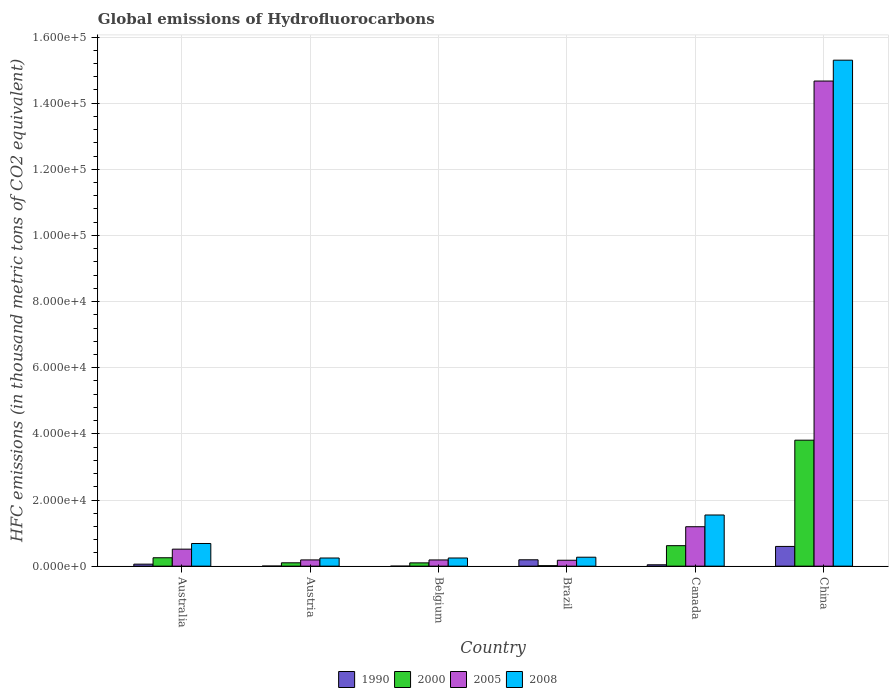What is the label of the 4th group of bars from the left?
Your response must be concise. Brazil. In how many cases, is the number of bars for a given country not equal to the number of legend labels?
Your response must be concise. 0. What is the global emissions of Hydrofluorocarbons in 1990 in Canada?
Your answer should be compact. 418.5. Across all countries, what is the maximum global emissions of Hydrofluorocarbons in 1990?
Give a very brief answer. 5970.1. Across all countries, what is the minimum global emissions of Hydrofluorocarbons in 2005?
Make the answer very short. 1793.4. In which country was the global emissions of Hydrofluorocarbons in 1990 maximum?
Your answer should be very brief. China. In which country was the global emissions of Hydrofluorocarbons in 2000 minimum?
Ensure brevity in your answer.  Brazil. What is the total global emissions of Hydrofluorocarbons in 2000 in the graph?
Offer a terse response. 4.90e+04. What is the difference between the global emissions of Hydrofluorocarbons in 2005 in Australia and that in China?
Your response must be concise. -1.42e+05. What is the difference between the global emissions of Hydrofluorocarbons in 2000 in Belgium and the global emissions of Hydrofluorocarbons in 2008 in Austria?
Make the answer very short. -1471.2. What is the average global emissions of Hydrofluorocarbons in 2000 per country?
Offer a very short reply. 8167.67. What is the difference between the global emissions of Hydrofluorocarbons of/in 2005 and global emissions of Hydrofluorocarbons of/in 2000 in Brazil?
Provide a short and direct response. 1646. In how many countries, is the global emissions of Hydrofluorocarbons in 1990 greater than 112000 thousand metric tons?
Your response must be concise. 0. What is the ratio of the global emissions of Hydrofluorocarbons in 2000 in Austria to that in Brazil?
Offer a very short reply. 6.91. What is the difference between the highest and the second highest global emissions of Hydrofluorocarbons in 1990?
Offer a very short reply. 5357.6. What is the difference between the highest and the lowest global emissions of Hydrofluorocarbons in 2000?
Your answer should be very brief. 3.79e+04. In how many countries, is the global emissions of Hydrofluorocarbons in 2000 greater than the average global emissions of Hydrofluorocarbons in 2000 taken over all countries?
Provide a succinct answer. 1. Is the sum of the global emissions of Hydrofluorocarbons in 2000 in Australia and Belgium greater than the maximum global emissions of Hydrofluorocarbons in 1990 across all countries?
Your response must be concise. No. Are all the bars in the graph horizontal?
Ensure brevity in your answer.  No. How many countries are there in the graph?
Keep it short and to the point. 6. What is the difference between two consecutive major ticks on the Y-axis?
Keep it short and to the point. 2.00e+04. Does the graph contain grids?
Provide a succinct answer. Yes. How many legend labels are there?
Give a very brief answer. 4. What is the title of the graph?
Make the answer very short. Global emissions of Hydrofluorocarbons. Does "1995" appear as one of the legend labels in the graph?
Your answer should be very brief. No. What is the label or title of the Y-axis?
Provide a short and direct response. HFC emissions (in thousand metric tons of CO2 equivalent). What is the HFC emissions (in thousand metric tons of CO2 equivalent) in 1990 in Australia?
Provide a succinct answer. 612.5. What is the HFC emissions (in thousand metric tons of CO2 equivalent) in 2000 in Australia?
Your answer should be compact. 2545.7. What is the HFC emissions (in thousand metric tons of CO2 equivalent) of 2005 in Australia?
Provide a short and direct response. 5145.6. What is the HFC emissions (in thousand metric tons of CO2 equivalent) in 2008 in Australia?
Provide a succinct answer. 6857.4. What is the HFC emissions (in thousand metric tons of CO2 equivalent) in 1990 in Austria?
Keep it short and to the point. 30.9. What is the HFC emissions (in thousand metric tons of CO2 equivalent) of 2000 in Austria?
Provide a short and direct response. 1018.4. What is the HFC emissions (in thousand metric tons of CO2 equivalent) of 2005 in Austria?
Your answer should be compact. 1891.2. What is the HFC emissions (in thousand metric tons of CO2 equivalent) of 2008 in Austria?
Offer a terse response. 2468.9. What is the HFC emissions (in thousand metric tons of CO2 equivalent) of 2000 in Belgium?
Provide a short and direct response. 997.7. What is the HFC emissions (in thousand metric tons of CO2 equivalent) of 2005 in Belgium?
Make the answer very short. 1882.6. What is the HFC emissions (in thousand metric tons of CO2 equivalent) of 2008 in Belgium?
Provide a short and direct response. 2471.1. What is the HFC emissions (in thousand metric tons of CO2 equivalent) of 1990 in Brazil?
Provide a short and direct response. 1930.7. What is the HFC emissions (in thousand metric tons of CO2 equivalent) of 2000 in Brazil?
Provide a succinct answer. 147.4. What is the HFC emissions (in thousand metric tons of CO2 equivalent) in 2005 in Brazil?
Your answer should be very brief. 1793.4. What is the HFC emissions (in thousand metric tons of CO2 equivalent) in 2008 in Brazil?
Make the answer very short. 2707.5. What is the HFC emissions (in thousand metric tons of CO2 equivalent) of 1990 in Canada?
Your response must be concise. 418.5. What is the HFC emissions (in thousand metric tons of CO2 equivalent) of 2000 in Canada?
Your answer should be compact. 6202.8. What is the HFC emissions (in thousand metric tons of CO2 equivalent) of 2005 in Canada?
Offer a terse response. 1.19e+04. What is the HFC emissions (in thousand metric tons of CO2 equivalent) of 2008 in Canada?
Your answer should be compact. 1.55e+04. What is the HFC emissions (in thousand metric tons of CO2 equivalent) in 1990 in China?
Provide a succinct answer. 5970.1. What is the HFC emissions (in thousand metric tons of CO2 equivalent) in 2000 in China?
Offer a terse response. 3.81e+04. What is the HFC emissions (in thousand metric tons of CO2 equivalent) in 2005 in China?
Provide a succinct answer. 1.47e+05. What is the HFC emissions (in thousand metric tons of CO2 equivalent) of 2008 in China?
Make the answer very short. 1.53e+05. Across all countries, what is the maximum HFC emissions (in thousand metric tons of CO2 equivalent) in 1990?
Offer a very short reply. 5970.1. Across all countries, what is the maximum HFC emissions (in thousand metric tons of CO2 equivalent) in 2000?
Make the answer very short. 3.81e+04. Across all countries, what is the maximum HFC emissions (in thousand metric tons of CO2 equivalent) in 2005?
Your answer should be compact. 1.47e+05. Across all countries, what is the maximum HFC emissions (in thousand metric tons of CO2 equivalent) in 2008?
Make the answer very short. 1.53e+05. Across all countries, what is the minimum HFC emissions (in thousand metric tons of CO2 equivalent) of 2000?
Offer a very short reply. 147.4. Across all countries, what is the minimum HFC emissions (in thousand metric tons of CO2 equivalent) of 2005?
Give a very brief answer. 1793.4. Across all countries, what is the minimum HFC emissions (in thousand metric tons of CO2 equivalent) in 2008?
Provide a short and direct response. 2468.9. What is the total HFC emissions (in thousand metric tons of CO2 equivalent) in 1990 in the graph?
Make the answer very short. 8963.2. What is the total HFC emissions (in thousand metric tons of CO2 equivalent) of 2000 in the graph?
Offer a very short reply. 4.90e+04. What is the total HFC emissions (in thousand metric tons of CO2 equivalent) of 2005 in the graph?
Your response must be concise. 1.69e+05. What is the total HFC emissions (in thousand metric tons of CO2 equivalent) in 2008 in the graph?
Provide a succinct answer. 1.83e+05. What is the difference between the HFC emissions (in thousand metric tons of CO2 equivalent) of 1990 in Australia and that in Austria?
Ensure brevity in your answer.  581.6. What is the difference between the HFC emissions (in thousand metric tons of CO2 equivalent) of 2000 in Australia and that in Austria?
Your response must be concise. 1527.3. What is the difference between the HFC emissions (in thousand metric tons of CO2 equivalent) of 2005 in Australia and that in Austria?
Keep it short and to the point. 3254.4. What is the difference between the HFC emissions (in thousand metric tons of CO2 equivalent) of 2008 in Australia and that in Austria?
Make the answer very short. 4388.5. What is the difference between the HFC emissions (in thousand metric tons of CO2 equivalent) in 1990 in Australia and that in Belgium?
Provide a short and direct response. 612. What is the difference between the HFC emissions (in thousand metric tons of CO2 equivalent) in 2000 in Australia and that in Belgium?
Keep it short and to the point. 1548. What is the difference between the HFC emissions (in thousand metric tons of CO2 equivalent) in 2005 in Australia and that in Belgium?
Offer a very short reply. 3263. What is the difference between the HFC emissions (in thousand metric tons of CO2 equivalent) of 2008 in Australia and that in Belgium?
Offer a very short reply. 4386.3. What is the difference between the HFC emissions (in thousand metric tons of CO2 equivalent) in 1990 in Australia and that in Brazil?
Your response must be concise. -1318.2. What is the difference between the HFC emissions (in thousand metric tons of CO2 equivalent) in 2000 in Australia and that in Brazil?
Offer a terse response. 2398.3. What is the difference between the HFC emissions (in thousand metric tons of CO2 equivalent) of 2005 in Australia and that in Brazil?
Make the answer very short. 3352.2. What is the difference between the HFC emissions (in thousand metric tons of CO2 equivalent) of 2008 in Australia and that in Brazil?
Provide a short and direct response. 4149.9. What is the difference between the HFC emissions (in thousand metric tons of CO2 equivalent) of 1990 in Australia and that in Canada?
Your response must be concise. 194. What is the difference between the HFC emissions (in thousand metric tons of CO2 equivalent) of 2000 in Australia and that in Canada?
Your response must be concise. -3657.1. What is the difference between the HFC emissions (in thousand metric tons of CO2 equivalent) of 2005 in Australia and that in Canada?
Provide a succinct answer. -6782.8. What is the difference between the HFC emissions (in thousand metric tons of CO2 equivalent) of 2008 in Australia and that in Canada?
Make the answer very short. -8617.4. What is the difference between the HFC emissions (in thousand metric tons of CO2 equivalent) in 1990 in Australia and that in China?
Your response must be concise. -5357.6. What is the difference between the HFC emissions (in thousand metric tons of CO2 equivalent) in 2000 in Australia and that in China?
Your response must be concise. -3.55e+04. What is the difference between the HFC emissions (in thousand metric tons of CO2 equivalent) in 2005 in Australia and that in China?
Make the answer very short. -1.42e+05. What is the difference between the HFC emissions (in thousand metric tons of CO2 equivalent) of 2008 in Australia and that in China?
Offer a very short reply. -1.46e+05. What is the difference between the HFC emissions (in thousand metric tons of CO2 equivalent) in 1990 in Austria and that in Belgium?
Provide a short and direct response. 30.4. What is the difference between the HFC emissions (in thousand metric tons of CO2 equivalent) of 2000 in Austria and that in Belgium?
Keep it short and to the point. 20.7. What is the difference between the HFC emissions (in thousand metric tons of CO2 equivalent) in 2008 in Austria and that in Belgium?
Keep it short and to the point. -2.2. What is the difference between the HFC emissions (in thousand metric tons of CO2 equivalent) in 1990 in Austria and that in Brazil?
Keep it short and to the point. -1899.8. What is the difference between the HFC emissions (in thousand metric tons of CO2 equivalent) of 2000 in Austria and that in Brazil?
Your response must be concise. 871. What is the difference between the HFC emissions (in thousand metric tons of CO2 equivalent) in 2005 in Austria and that in Brazil?
Give a very brief answer. 97.8. What is the difference between the HFC emissions (in thousand metric tons of CO2 equivalent) of 2008 in Austria and that in Brazil?
Provide a succinct answer. -238.6. What is the difference between the HFC emissions (in thousand metric tons of CO2 equivalent) of 1990 in Austria and that in Canada?
Give a very brief answer. -387.6. What is the difference between the HFC emissions (in thousand metric tons of CO2 equivalent) of 2000 in Austria and that in Canada?
Give a very brief answer. -5184.4. What is the difference between the HFC emissions (in thousand metric tons of CO2 equivalent) of 2005 in Austria and that in Canada?
Keep it short and to the point. -1.00e+04. What is the difference between the HFC emissions (in thousand metric tons of CO2 equivalent) of 2008 in Austria and that in Canada?
Ensure brevity in your answer.  -1.30e+04. What is the difference between the HFC emissions (in thousand metric tons of CO2 equivalent) in 1990 in Austria and that in China?
Give a very brief answer. -5939.2. What is the difference between the HFC emissions (in thousand metric tons of CO2 equivalent) in 2000 in Austria and that in China?
Provide a succinct answer. -3.71e+04. What is the difference between the HFC emissions (in thousand metric tons of CO2 equivalent) in 2005 in Austria and that in China?
Your answer should be compact. -1.45e+05. What is the difference between the HFC emissions (in thousand metric tons of CO2 equivalent) in 2008 in Austria and that in China?
Keep it short and to the point. -1.51e+05. What is the difference between the HFC emissions (in thousand metric tons of CO2 equivalent) in 1990 in Belgium and that in Brazil?
Keep it short and to the point. -1930.2. What is the difference between the HFC emissions (in thousand metric tons of CO2 equivalent) in 2000 in Belgium and that in Brazil?
Provide a short and direct response. 850.3. What is the difference between the HFC emissions (in thousand metric tons of CO2 equivalent) of 2005 in Belgium and that in Brazil?
Give a very brief answer. 89.2. What is the difference between the HFC emissions (in thousand metric tons of CO2 equivalent) in 2008 in Belgium and that in Brazil?
Your response must be concise. -236.4. What is the difference between the HFC emissions (in thousand metric tons of CO2 equivalent) in 1990 in Belgium and that in Canada?
Keep it short and to the point. -418. What is the difference between the HFC emissions (in thousand metric tons of CO2 equivalent) in 2000 in Belgium and that in Canada?
Offer a very short reply. -5205.1. What is the difference between the HFC emissions (in thousand metric tons of CO2 equivalent) in 2005 in Belgium and that in Canada?
Provide a succinct answer. -1.00e+04. What is the difference between the HFC emissions (in thousand metric tons of CO2 equivalent) in 2008 in Belgium and that in Canada?
Provide a succinct answer. -1.30e+04. What is the difference between the HFC emissions (in thousand metric tons of CO2 equivalent) of 1990 in Belgium and that in China?
Ensure brevity in your answer.  -5969.6. What is the difference between the HFC emissions (in thousand metric tons of CO2 equivalent) in 2000 in Belgium and that in China?
Ensure brevity in your answer.  -3.71e+04. What is the difference between the HFC emissions (in thousand metric tons of CO2 equivalent) of 2005 in Belgium and that in China?
Your answer should be very brief. -1.45e+05. What is the difference between the HFC emissions (in thousand metric tons of CO2 equivalent) of 2008 in Belgium and that in China?
Offer a terse response. -1.51e+05. What is the difference between the HFC emissions (in thousand metric tons of CO2 equivalent) in 1990 in Brazil and that in Canada?
Make the answer very short. 1512.2. What is the difference between the HFC emissions (in thousand metric tons of CO2 equivalent) in 2000 in Brazil and that in Canada?
Offer a very short reply. -6055.4. What is the difference between the HFC emissions (in thousand metric tons of CO2 equivalent) in 2005 in Brazil and that in Canada?
Your answer should be compact. -1.01e+04. What is the difference between the HFC emissions (in thousand metric tons of CO2 equivalent) of 2008 in Brazil and that in Canada?
Keep it short and to the point. -1.28e+04. What is the difference between the HFC emissions (in thousand metric tons of CO2 equivalent) in 1990 in Brazil and that in China?
Offer a very short reply. -4039.4. What is the difference between the HFC emissions (in thousand metric tons of CO2 equivalent) of 2000 in Brazil and that in China?
Provide a short and direct response. -3.79e+04. What is the difference between the HFC emissions (in thousand metric tons of CO2 equivalent) of 2005 in Brazil and that in China?
Provide a succinct answer. -1.45e+05. What is the difference between the HFC emissions (in thousand metric tons of CO2 equivalent) in 2008 in Brazil and that in China?
Offer a very short reply. -1.50e+05. What is the difference between the HFC emissions (in thousand metric tons of CO2 equivalent) of 1990 in Canada and that in China?
Provide a short and direct response. -5551.6. What is the difference between the HFC emissions (in thousand metric tons of CO2 equivalent) in 2000 in Canada and that in China?
Make the answer very short. -3.19e+04. What is the difference between the HFC emissions (in thousand metric tons of CO2 equivalent) in 2005 in Canada and that in China?
Offer a very short reply. -1.35e+05. What is the difference between the HFC emissions (in thousand metric tons of CO2 equivalent) of 2008 in Canada and that in China?
Your answer should be very brief. -1.38e+05. What is the difference between the HFC emissions (in thousand metric tons of CO2 equivalent) of 1990 in Australia and the HFC emissions (in thousand metric tons of CO2 equivalent) of 2000 in Austria?
Make the answer very short. -405.9. What is the difference between the HFC emissions (in thousand metric tons of CO2 equivalent) of 1990 in Australia and the HFC emissions (in thousand metric tons of CO2 equivalent) of 2005 in Austria?
Give a very brief answer. -1278.7. What is the difference between the HFC emissions (in thousand metric tons of CO2 equivalent) in 1990 in Australia and the HFC emissions (in thousand metric tons of CO2 equivalent) in 2008 in Austria?
Offer a terse response. -1856.4. What is the difference between the HFC emissions (in thousand metric tons of CO2 equivalent) in 2000 in Australia and the HFC emissions (in thousand metric tons of CO2 equivalent) in 2005 in Austria?
Offer a terse response. 654.5. What is the difference between the HFC emissions (in thousand metric tons of CO2 equivalent) of 2000 in Australia and the HFC emissions (in thousand metric tons of CO2 equivalent) of 2008 in Austria?
Ensure brevity in your answer.  76.8. What is the difference between the HFC emissions (in thousand metric tons of CO2 equivalent) of 2005 in Australia and the HFC emissions (in thousand metric tons of CO2 equivalent) of 2008 in Austria?
Provide a succinct answer. 2676.7. What is the difference between the HFC emissions (in thousand metric tons of CO2 equivalent) of 1990 in Australia and the HFC emissions (in thousand metric tons of CO2 equivalent) of 2000 in Belgium?
Offer a terse response. -385.2. What is the difference between the HFC emissions (in thousand metric tons of CO2 equivalent) of 1990 in Australia and the HFC emissions (in thousand metric tons of CO2 equivalent) of 2005 in Belgium?
Keep it short and to the point. -1270.1. What is the difference between the HFC emissions (in thousand metric tons of CO2 equivalent) in 1990 in Australia and the HFC emissions (in thousand metric tons of CO2 equivalent) in 2008 in Belgium?
Provide a short and direct response. -1858.6. What is the difference between the HFC emissions (in thousand metric tons of CO2 equivalent) in 2000 in Australia and the HFC emissions (in thousand metric tons of CO2 equivalent) in 2005 in Belgium?
Offer a terse response. 663.1. What is the difference between the HFC emissions (in thousand metric tons of CO2 equivalent) of 2000 in Australia and the HFC emissions (in thousand metric tons of CO2 equivalent) of 2008 in Belgium?
Your response must be concise. 74.6. What is the difference between the HFC emissions (in thousand metric tons of CO2 equivalent) in 2005 in Australia and the HFC emissions (in thousand metric tons of CO2 equivalent) in 2008 in Belgium?
Your response must be concise. 2674.5. What is the difference between the HFC emissions (in thousand metric tons of CO2 equivalent) in 1990 in Australia and the HFC emissions (in thousand metric tons of CO2 equivalent) in 2000 in Brazil?
Your answer should be very brief. 465.1. What is the difference between the HFC emissions (in thousand metric tons of CO2 equivalent) of 1990 in Australia and the HFC emissions (in thousand metric tons of CO2 equivalent) of 2005 in Brazil?
Your response must be concise. -1180.9. What is the difference between the HFC emissions (in thousand metric tons of CO2 equivalent) of 1990 in Australia and the HFC emissions (in thousand metric tons of CO2 equivalent) of 2008 in Brazil?
Make the answer very short. -2095. What is the difference between the HFC emissions (in thousand metric tons of CO2 equivalent) of 2000 in Australia and the HFC emissions (in thousand metric tons of CO2 equivalent) of 2005 in Brazil?
Offer a terse response. 752.3. What is the difference between the HFC emissions (in thousand metric tons of CO2 equivalent) of 2000 in Australia and the HFC emissions (in thousand metric tons of CO2 equivalent) of 2008 in Brazil?
Provide a short and direct response. -161.8. What is the difference between the HFC emissions (in thousand metric tons of CO2 equivalent) of 2005 in Australia and the HFC emissions (in thousand metric tons of CO2 equivalent) of 2008 in Brazil?
Make the answer very short. 2438.1. What is the difference between the HFC emissions (in thousand metric tons of CO2 equivalent) in 1990 in Australia and the HFC emissions (in thousand metric tons of CO2 equivalent) in 2000 in Canada?
Your response must be concise. -5590.3. What is the difference between the HFC emissions (in thousand metric tons of CO2 equivalent) in 1990 in Australia and the HFC emissions (in thousand metric tons of CO2 equivalent) in 2005 in Canada?
Provide a short and direct response. -1.13e+04. What is the difference between the HFC emissions (in thousand metric tons of CO2 equivalent) of 1990 in Australia and the HFC emissions (in thousand metric tons of CO2 equivalent) of 2008 in Canada?
Provide a short and direct response. -1.49e+04. What is the difference between the HFC emissions (in thousand metric tons of CO2 equivalent) in 2000 in Australia and the HFC emissions (in thousand metric tons of CO2 equivalent) in 2005 in Canada?
Give a very brief answer. -9382.7. What is the difference between the HFC emissions (in thousand metric tons of CO2 equivalent) of 2000 in Australia and the HFC emissions (in thousand metric tons of CO2 equivalent) of 2008 in Canada?
Give a very brief answer. -1.29e+04. What is the difference between the HFC emissions (in thousand metric tons of CO2 equivalent) of 2005 in Australia and the HFC emissions (in thousand metric tons of CO2 equivalent) of 2008 in Canada?
Provide a succinct answer. -1.03e+04. What is the difference between the HFC emissions (in thousand metric tons of CO2 equivalent) in 1990 in Australia and the HFC emissions (in thousand metric tons of CO2 equivalent) in 2000 in China?
Give a very brief answer. -3.75e+04. What is the difference between the HFC emissions (in thousand metric tons of CO2 equivalent) in 1990 in Australia and the HFC emissions (in thousand metric tons of CO2 equivalent) in 2005 in China?
Your response must be concise. -1.46e+05. What is the difference between the HFC emissions (in thousand metric tons of CO2 equivalent) of 1990 in Australia and the HFC emissions (in thousand metric tons of CO2 equivalent) of 2008 in China?
Offer a terse response. -1.52e+05. What is the difference between the HFC emissions (in thousand metric tons of CO2 equivalent) of 2000 in Australia and the HFC emissions (in thousand metric tons of CO2 equivalent) of 2005 in China?
Offer a terse response. -1.44e+05. What is the difference between the HFC emissions (in thousand metric tons of CO2 equivalent) in 2000 in Australia and the HFC emissions (in thousand metric tons of CO2 equivalent) in 2008 in China?
Your answer should be very brief. -1.50e+05. What is the difference between the HFC emissions (in thousand metric tons of CO2 equivalent) in 2005 in Australia and the HFC emissions (in thousand metric tons of CO2 equivalent) in 2008 in China?
Your answer should be compact. -1.48e+05. What is the difference between the HFC emissions (in thousand metric tons of CO2 equivalent) of 1990 in Austria and the HFC emissions (in thousand metric tons of CO2 equivalent) of 2000 in Belgium?
Your answer should be very brief. -966.8. What is the difference between the HFC emissions (in thousand metric tons of CO2 equivalent) in 1990 in Austria and the HFC emissions (in thousand metric tons of CO2 equivalent) in 2005 in Belgium?
Provide a short and direct response. -1851.7. What is the difference between the HFC emissions (in thousand metric tons of CO2 equivalent) of 1990 in Austria and the HFC emissions (in thousand metric tons of CO2 equivalent) of 2008 in Belgium?
Offer a very short reply. -2440.2. What is the difference between the HFC emissions (in thousand metric tons of CO2 equivalent) in 2000 in Austria and the HFC emissions (in thousand metric tons of CO2 equivalent) in 2005 in Belgium?
Give a very brief answer. -864.2. What is the difference between the HFC emissions (in thousand metric tons of CO2 equivalent) of 2000 in Austria and the HFC emissions (in thousand metric tons of CO2 equivalent) of 2008 in Belgium?
Ensure brevity in your answer.  -1452.7. What is the difference between the HFC emissions (in thousand metric tons of CO2 equivalent) in 2005 in Austria and the HFC emissions (in thousand metric tons of CO2 equivalent) in 2008 in Belgium?
Your answer should be compact. -579.9. What is the difference between the HFC emissions (in thousand metric tons of CO2 equivalent) of 1990 in Austria and the HFC emissions (in thousand metric tons of CO2 equivalent) of 2000 in Brazil?
Provide a succinct answer. -116.5. What is the difference between the HFC emissions (in thousand metric tons of CO2 equivalent) in 1990 in Austria and the HFC emissions (in thousand metric tons of CO2 equivalent) in 2005 in Brazil?
Keep it short and to the point. -1762.5. What is the difference between the HFC emissions (in thousand metric tons of CO2 equivalent) in 1990 in Austria and the HFC emissions (in thousand metric tons of CO2 equivalent) in 2008 in Brazil?
Keep it short and to the point. -2676.6. What is the difference between the HFC emissions (in thousand metric tons of CO2 equivalent) in 2000 in Austria and the HFC emissions (in thousand metric tons of CO2 equivalent) in 2005 in Brazil?
Offer a terse response. -775. What is the difference between the HFC emissions (in thousand metric tons of CO2 equivalent) in 2000 in Austria and the HFC emissions (in thousand metric tons of CO2 equivalent) in 2008 in Brazil?
Offer a terse response. -1689.1. What is the difference between the HFC emissions (in thousand metric tons of CO2 equivalent) of 2005 in Austria and the HFC emissions (in thousand metric tons of CO2 equivalent) of 2008 in Brazil?
Your answer should be very brief. -816.3. What is the difference between the HFC emissions (in thousand metric tons of CO2 equivalent) of 1990 in Austria and the HFC emissions (in thousand metric tons of CO2 equivalent) of 2000 in Canada?
Give a very brief answer. -6171.9. What is the difference between the HFC emissions (in thousand metric tons of CO2 equivalent) of 1990 in Austria and the HFC emissions (in thousand metric tons of CO2 equivalent) of 2005 in Canada?
Provide a short and direct response. -1.19e+04. What is the difference between the HFC emissions (in thousand metric tons of CO2 equivalent) of 1990 in Austria and the HFC emissions (in thousand metric tons of CO2 equivalent) of 2008 in Canada?
Keep it short and to the point. -1.54e+04. What is the difference between the HFC emissions (in thousand metric tons of CO2 equivalent) in 2000 in Austria and the HFC emissions (in thousand metric tons of CO2 equivalent) in 2005 in Canada?
Your answer should be compact. -1.09e+04. What is the difference between the HFC emissions (in thousand metric tons of CO2 equivalent) of 2000 in Austria and the HFC emissions (in thousand metric tons of CO2 equivalent) of 2008 in Canada?
Provide a succinct answer. -1.45e+04. What is the difference between the HFC emissions (in thousand metric tons of CO2 equivalent) in 2005 in Austria and the HFC emissions (in thousand metric tons of CO2 equivalent) in 2008 in Canada?
Provide a succinct answer. -1.36e+04. What is the difference between the HFC emissions (in thousand metric tons of CO2 equivalent) in 1990 in Austria and the HFC emissions (in thousand metric tons of CO2 equivalent) in 2000 in China?
Provide a short and direct response. -3.81e+04. What is the difference between the HFC emissions (in thousand metric tons of CO2 equivalent) of 1990 in Austria and the HFC emissions (in thousand metric tons of CO2 equivalent) of 2005 in China?
Offer a very short reply. -1.47e+05. What is the difference between the HFC emissions (in thousand metric tons of CO2 equivalent) of 1990 in Austria and the HFC emissions (in thousand metric tons of CO2 equivalent) of 2008 in China?
Ensure brevity in your answer.  -1.53e+05. What is the difference between the HFC emissions (in thousand metric tons of CO2 equivalent) in 2000 in Austria and the HFC emissions (in thousand metric tons of CO2 equivalent) in 2005 in China?
Offer a very short reply. -1.46e+05. What is the difference between the HFC emissions (in thousand metric tons of CO2 equivalent) of 2000 in Austria and the HFC emissions (in thousand metric tons of CO2 equivalent) of 2008 in China?
Make the answer very short. -1.52e+05. What is the difference between the HFC emissions (in thousand metric tons of CO2 equivalent) of 2005 in Austria and the HFC emissions (in thousand metric tons of CO2 equivalent) of 2008 in China?
Make the answer very short. -1.51e+05. What is the difference between the HFC emissions (in thousand metric tons of CO2 equivalent) in 1990 in Belgium and the HFC emissions (in thousand metric tons of CO2 equivalent) in 2000 in Brazil?
Your answer should be compact. -146.9. What is the difference between the HFC emissions (in thousand metric tons of CO2 equivalent) of 1990 in Belgium and the HFC emissions (in thousand metric tons of CO2 equivalent) of 2005 in Brazil?
Give a very brief answer. -1792.9. What is the difference between the HFC emissions (in thousand metric tons of CO2 equivalent) in 1990 in Belgium and the HFC emissions (in thousand metric tons of CO2 equivalent) in 2008 in Brazil?
Offer a very short reply. -2707. What is the difference between the HFC emissions (in thousand metric tons of CO2 equivalent) in 2000 in Belgium and the HFC emissions (in thousand metric tons of CO2 equivalent) in 2005 in Brazil?
Keep it short and to the point. -795.7. What is the difference between the HFC emissions (in thousand metric tons of CO2 equivalent) in 2000 in Belgium and the HFC emissions (in thousand metric tons of CO2 equivalent) in 2008 in Brazil?
Your answer should be compact. -1709.8. What is the difference between the HFC emissions (in thousand metric tons of CO2 equivalent) in 2005 in Belgium and the HFC emissions (in thousand metric tons of CO2 equivalent) in 2008 in Brazil?
Offer a very short reply. -824.9. What is the difference between the HFC emissions (in thousand metric tons of CO2 equivalent) of 1990 in Belgium and the HFC emissions (in thousand metric tons of CO2 equivalent) of 2000 in Canada?
Make the answer very short. -6202.3. What is the difference between the HFC emissions (in thousand metric tons of CO2 equivalent) in 1990 in Belgium and the HFC emissions (in thousand metric tons of CO2 equivalent) in 2005 in Canada?
Offer a terse response. -1.19e+04. What is the difference between the HFC emissions (in thousand metric tons of CO2 equivalent) in 1990 in Belgium and the HFC emissions (in thousand metric tons of CO2 equivalent) in 2008 in Canada?
Give a very brief answer. -1.55e+04. What is the difference between the HFC emissions (in thousand metric tons of CO2 equivalent) in 2000 in Belgium and the HFC emissions (in thousand metric tons of CO2 equivalent) in 2005 in Canada?
Provide a short and direct response. -1.09e+04. What is the difference between the HFC emissions (in thousand metric tons of CO2 equivalent) of 2000 in Belgium and the HFC emissions (in thousand metric tons of CO2 equivalent) of 2008 in Canada?
Your answer should be very brief. -1.45e+04. What is the difference between the HFC emissions (in thousand metric tons of CO2 equivalent) of 2005 in Belgium and the HFC emissions (in thousand metric tons of CO2 equivalent) of 2008 in Canada?
Provide a succinct answer. -1.36e+04. What is the difference between the HFC emissions (in thousand metric tons of CO2 equivalent) in 1990 in Belgium and the HFC emissions (in thousand metric tons of CO2 equivalent) in 2000 in China?
Provide a short and direct response. -3.81e+04. What is the difference between the HFC emissions (in thousand metric tons of CO2 equivalent) in 1990 in Belgium and the HFC emissions (in thousand metric tons of CO2 equivalent) in 2005 in China?
Provide a short and direct response. -1.47e+05. What is the difference between the HFC emissions (in thousand metric tons of CO2 equivalent) of 1990 in Belgium and the HFC emissions (in thousand metric tons of CO2 equivalent) of 2008 in China?
Ensure brevity in your answer.  -1.53e+05. What is the difference between the HFC emissions (in thousand metric tons of CO2 equivalent) of 2000 in Belgium and the HFC emissions (in thousand metric tons of CO2 equivalent) of 2005 in China?
Give a very brief answer. -1.46e+05. What is the difference between the HFC emissions (in thousand metric tons of CO2 equivalent) in 2000 in Belgium and the HFC emissions (in thousand metric tons of CO2 equivalent) in 2008 in China?
Make the answer very short. -1.52e+05. What is the difference between the HFC emissions (in thousand metric tons of CO2 equivalent) in 2005 in Belgium and the HFC emissions (in thousand metric tons of CO2 equivalent) in 2008 in China?
Offer a very short reply. -1.51e+05. What is the difference between the HFC emissions (in thousand metric tons of CO2 equivalent) of 1990 in Brazil and the HFC emissions (in thousand metric tons of CO2 equivalent) of 2000 in Canada?
Make the answer very short. -4272.1. What is the difference between the HFC emissions (in thousand metric tons of CO2 equivalent) in 1990 in Brazil and the HFC emissions (in thousand metric tons of CO2 equivalent) in 2005 in Canada?
Ensure brevity in your answer.  -9997.7. What is the difference between the HFC emissions (in thousand metric tons of CO2 equivalent) of 1990 in Brazil and the HFC emissions (in thousand metric tons of CO2 equivalent) of 2008 in Canada?
Your response must be concise. -1.35e+04. What is the difference between the HFC emissions (in thousand metric tons of CO2 equivalent) of 2000 in Brazil and the HFC emissions (in thousand metric tons of CO2 equivalent) of 2005 in Canada?
Provide a succinct answer. -1.18e+04. What is the difference between the HFC emissions (in thousand metric tons of CO2 equivalent) of 2000 in Brazil and the HFC emissions (in thousand metric tons of CO2 equivalent) of 2008 in Canada?
Offer a terse response. -1.53e+04. What is the difference between the HFC emissions (in thousand metric tons of CO2 equivalent) of 2005 in Brazil and the HFC emissions (in thousand metric tons of CO2 equivalent) of 2008 in Canada?
Offer a very short reply. -1.37e+04. What is the difference between the HFC emissions (in thousand metric tons of CO2 equivalent) of 1990 in Brazil and the HFC emissions (in thousand metric tons of CO2 equivalent) of 2000 in China?
Give a very brief answer. -3.62e+04. What is the difference between the HFC emissions (in thousand metric tons of CO2 equivalent) in 1990 in Brazil and the HFC emissions (in thousand metric tons of CO2 equivalent) in 2005 in China?
Your response must be concise. -1.45e+05. What is the difference between the HFC emissions (in thousand metric tons of CO2 equivalent) of 1990 in Brazil and the HFC emissions (in thousand metric tons of CO2 equivalent) of 2008 in China?
Make the answer very short. -1.51e+05. What is the difference between the HFC emissions (in thousand metric tons of CO2 equivalent) in 2000 in Brazil and the HFC emissions (in thousand metric tons of CO2 equivalent) in 2005 in China?
Your answer should be compact. -1.47e+05. What is the difference between the HFC emissions (in thousand metric tons of CO2 equivalent) in 2000 in Brazil and the HFC emissions (in thousand metric tons of CO2 equivalent) in 2008 in China?
Your response must be concise. -1.53e+05. What is the difference between the HFC emissions (in thousand metric tons of CO2 equivalent) of 2005 in Brazil and the HFC emissions (in thousand metric tons of CO2 equivalent) of 2008 in China?
Your answer should be compact. -1.51e+05. What is the difference between the HFC emissions (in thousand metric tons of CO2 equivalent) of 1990 in Canada and the HFC emissions (in thousand metric tons of CO2 equivalent) of 2000 in China?
Your answer should be compact. -3.77e+04. What is the difference between the HFC emissions (in thousand metric tons of CO2 equivalent) of 1990 in Canada and the HFC emissions (in thousand metric tons of CO2 equivalent) of 2005 in China?
Give a very brief answer. -1.46e+05. What is the difference between the HFC emissions (in thousand metric tons of CO2 equivalent) of 1990 in Canada and the HFC emissions (in thousand metric tons of CO2 equivalent) of 2008 in China?
Give a very brief answer. -1.53e+05. What is the difference between the HFC emissions (in thousand metric tons of CO2 equivalent) in 2000 in Canada and the HFC emissions (in thousand metric tons of CO2 equivalent) in 2005 in China?
Provide a succinct answer. -1.40e+05. What is the difference between the HFC emissions (in thousand metric tons of CO2 equivalent) in 2000 in Canada and the HFC emissions (in thousand metric tons of CO2 equivalent) in 2008 in China?
Keep it short and to the point. -1.47e+05. What is the difference between the HFC emissions (in thousand metric tons of CO2 equivalent) of 2005 in Canada and the HFC emissions (in thousand metric tons of CO2 equivalent) of 2008 in China?
Provide a short and direct response. -1.41e+05. What is the average HFC emissions (in thousand metric tons of CO2 equivalent) of 1990 per country?
Make the answer very short. 1493.87. What is the average HFC emissions (in thousand metric tons of CO2 equivalent) in 2000 per country?
Provide a succinct answer. 8167.67. What is the average HFC emissions (in thousand metric tons of CO2 equivalent) in 2005 per country?
Provide a short and direct response. 2.82e+04. What is the average HFC emissions (in thousand metric tons of CO2 equivalent) in 2008 per country?
Ensure brevity in your answer.  3.05e+04. What is the difference between the HFC emissions (in thousand metric tons of CO2 equivalent) of 1990 and HFC emissions (in thousand metric tons of CO2 equivalent) of 2000 in Australia?
Your answer should be very brief. -1933.2. What is the difference between the HFC emissions (in thousand metric tons of CO2 equivalent) in 1990 and HFC emissions (in thousand metric tons of CO2 equivalent) in 2005 in Australia?
Provide a short and direct response. -4533.1. What is the difference between the HFC emissions (in thousand metric tons of CO2 equivalent) in 1990 and HFC emissions (in thousand metric tons of CO2 equivalent) in 2008 in Australia?
Offer a very short reply. -6244.9. What is the difference between the HFC emissions (in thousand metric tons of CO2 equivalent) of 2000 and HFC emissions (in thousand metric tons of CO2 equivalent) of 2005 in Australia?
Provide a short and direct response. -2599.9. What is the difference between the HFC emissions (in thousand metric tons of CO2 equivalent) of 2000 and HFC emissions (in thousand metric tons of CO2 equivalent) of 2008 in Australia?
Make the answer very short. -4311.7. What is the difference between the HFC emissions (in thousand metric tons of CO2 equivalent) of 2005 and HFC emissions (in thousand metric tons of CO2 equivalent) of 2008 in Australia?
Give a very brief answer. -1711.8. What is the difference between the HFC emissions (in thousand metric tons of CO2 equivalent) of 1990 and HFC emissions (in thousand metric tons of CO2 equivalent) of 2000 in Austria?
Keep it short and to the point. -987.5. What is the difference between the HFC emissions (in thousand metric tons of CO2 equivalent) of 1990 and HFC emissions (in thousand metric tons of CO2 equivalent) of 2005 in Austria?
Provide a succinct answer. -1860.3. What is the difference between the HFC emissions (in thousand metric tons of CO2 equivalent) of 1990 and HFC emissions (in thousand metric tons of CO2 equivalent) of 2008 in Austria?
Offer a terse response. -2438. What is the difference between the HFC emissions (in thousand metric tons of CO2 equivalent) of 2000 and HFC emissions (in thousand metric tons of CO2 equivalent) of 2005 in Austria?
Give a very brief answer. -872.8. What is the difference between the HFC emissions (in thousand metric tons of CO2 equivalent) of 2000 and HFC emissions (in thousand metric tons of CO2 equivalent) of 2008 in Austria?
Provide a short and direct response. -1450.5. What is the difference between the HFC emissions (in thousand metric tons of CO2 equivalent) in 2005 and HFC emissions (in thousand metric tons of CO2 equivalent) in 2008 in Austria?
Your answer should be compact. -577.7. What is the difference between the HFC emissions (in thousand metric tons of CO2 equivalent) in 1990 and HFC emissions (in thousand metric tons of CO2 equivalent) in 2000 in Belgium?
Your response must be concise. -997.2. What is the difference between the HFC emissions (in thousand metric tons of CO2 equivalent) of 1990 and HFC emissions (in thousand metric tons of CO2 equivalent) of 2005 in Belgium?
Keep it short and to the point. -1882.1. What is the difference between the HFC emissions (in thousand metric tons of CO2 equivalent) of 1990 and HFC emissions (in thousand metric tons of CO2 equivalent) of 2008 in Belgium?
Ensure brevity in your answer.  -2470.6. What is the difference between the HFC emissions (in thousand metric tons of CO2 equivalent) in 2000 and HFC emissions (in thousand metric tons of CO2 equivalent) in 2005 in Belgium?
Ensure brevity in your answer.  -884.9. What is the difference between the HFC emissions (in thousand metric tons of CO2 equivalent) of 2000 and HFC emissions (in thousand metric tons of CO2 equivalent) of 2008 in Belgium?
Keep it short and to the point. -1473.4. What is the difference between the HFC emissions (in thousand metric tons of CO2 equivalent) in 2005 and HFC emissions (in thousand metric tons of CO2 equivalent) in 2008 in Belgium?
Provide a succinct answer. -588.5. What is the difference between the HFC emissions (in thousand metric tons of CO2 equivalent) in 1990 and HFC emissions (in thousand metric tons of CO2 equivalent) in 2000 in Brazil?
Provide a succinct answer. 1783.3. What is the difference between the HFC emissions (in thousand metric tons of CO2 equivalent) of 1990 and HFC emissions (in thousand metric tons of CO2 equivalent) of 2005 in Brazil?
Ensure brevity in your answer.  137.3. What is the difference between the HFC emissions (in thousand metric tons of CO2 equivalent) of 1990 and HFC emissions (in thousand metric tons of CO2 equivalent) of 2008 in Brazil?
Your response must be concise. -776.8. What is the difference between the HFC emissions (in thousand metric tons of CO2 equivalent) of 2000 and HFC emissions (in thousand metric tons of CO2 equivalent) of 2005 in Brazil?
Keep it short and to the point. -1646. What is the difference between the HFC emissions (in thousand metric tons of CO2 equivalent) in 2000 and HFC emissions (in thousand metric tons of CO2 equivalent) in 2008 in Brazil?
Your response must be concise. -2560.1. What is the difference between the HFC emissions (in thousand metric tons of CO2 equivalent) in 2005 and HFC emissions (in thousand metric tons of CO2 equivalent) in 2008 in Brazil?
Offer a very short reply. -914.1. What is the difference between the HFC emissions (in thousand metric tons of CO2 equivalent) in 1990 and HFC emissions (in thousand metric tons of CO2 equivalent) in 2000 in Canada?
Your answer should be very brief. -5784.3. What is the difference between the HFC emissions (in thousand metric tons of CO2 equivalent) in 1990 and HFC emissions (in thousand metric tons of CO2 equivalent) in 2005 in Canada?
Offer a very short reply. -1.15e+04. What is the difference between the HFC emissions (in thousand metric tons of CO2 equivalent) of 1990 and HFC emissions (in thousand metric tons of CO2 equivalent) of 2008 in Canada?
Your response must be concise. -1.51e+04. What is the difference between the HFC emissions (in thousand metric tons of CO2 equivalent) of 2000 and HFC emissions (in thousand metric tons of CO2 equivalent) of 2005 in Canada?
Your response must be concise. -5725.6. What is the difference between the HFC emissions (in thousand metric tons of CO2 equivalent) in 2000 and HFC emissions (in thousand metric tons of CO2 equivalent) in 2008 in Canada?
Provide a succinct answer. -9272. What is the difference between the HFC emissions (in thousand metric tons of CO2 equivalent) of 2005 and HFC emissions (in thousand metric tons of CO2 equivalent) of 2008 in Canada?
Your response must be concise. -3546.4. What is the difference between the HFC emissions (in thousand metric tons of CO2 equivalent) in 1990 and HFC emissions (in thousand metric tons of CO2 equivalent) in 2000 in China?
Provide a succinct answer. -3.21e+04. What is the difference between the HFC emissions (in thousand metric tons of CO2 equivalent) in 1990 and HFC emissions (in thousand metric tons of CO2 equivalent) in 2005 in China?
Your response must be concise. -1.41e+05. What is the difference between the HFC emissions (in thousand metric tons of CO2 equivalent) of 1990 and HFC emissions (in thousand metric tons of CO2 equivalent) of 2008 in China?
Provide a short and direct response. -1.47e+05. What is the difference between the HFC emissions (in thousand metric tons of CO2 equivalent) of 2000 and HFC emissions (in thousand metric tons of CO2 equivalent) of 2005 in China?
Your answer should be very brief. -1.09e+05. What is the difference between the HFC emissions (in thousand metric tons of CO2 equivalent) in 2000 and HFC emissions (in thousand metric tons of CO2 equivalent) in 2008 in China?
Your response must be concise. -1.15e+05. What is the difference between the HFC emissions (in thousand metric tons of CO2 equivalent) of 2005 and HFC emissions (in thousand metric tons of CO2 equivalent) of 2008 in China?
Provide a succinct answer. -6309. What is the ratio of the HFC emissions (in thousand metric tons of CO2 equivalent) in 1990 in Australia to that in Austria?
Provide a succinct answer. 19.82. What is the ratio of the HFC emissions (in thousand metric tons of CO2 equivalent) in 2000 in Australia to that in Austria?
Your response must be concise. 2.5. What is the ratio of the HFC emissions (in thousand metric tons of CO2 equivalent) in 2005 in Australia to that in Austria?
Offer a very short reply. 2.72. What is the ratio of the HFC emissions (in thousand metric tons of CO2 equivalent) in 2008 in Australia to that in Austria?
Provide a succinct answer. 2.78. What is the ratio of the HFC emissions (in thousand metric tons of CO2 equivalent) of 1990 in Australia to that in Belgium?
Offer a very short reply. 1225. What is the ratio of the HFC emissions (in thousand metric tons of CO2 equivalent) in 2000 in Australia to that in Belgium?
Your response must be concise. 2.55. What is the ratio of the HFC emissions (in thousand metric tons of CO2 equivalent) of 2005 in Australia to that in Belgium?
Give a very brief answer. 2.73. What is the ratio of the HFC emissions (in thousand metric tons of CO2 equivalent) of 2008 in Australia to that in Belgium?
Your answer should be compact. 2.77. What is the ratio of the HFC emissions (in thousand metric tons of CO2 equivalent) in 1990 in Australia to that in Brazil?
Ensure brevity in your answer.  0.32. What is the ratio of the HFC emissions (in thousand metric tons of CO2 equivalent) in 2000 in Australia to that in Brazil?
Your answer should be compact. 17.27. What is the ratio of the HFC emissions (in thousand metric tons of CO2 equivalent) in 2005 in Australia to that in Brazil?
Keep it short and to the point. 2.87. What is the ratio of the HFC emissions (in thousand metric tons of CO2 equivalent) of 2008 in Australia to that in Brazil?
Make the answer very short. 2.53. What is the ratio of the HFC emissions (in thousand metric tons of CO2 equivalent) of 1990 in Australia to that in Canada?
Give a very brief answer. 1.46. What is the ratio of the HFC emissions (in thousand metric tons of CO2 equivalent) in 2000 in Australia to that in Canada?
Your answer should be very brief. 0.41. What is the ratio of the HFC emissions (in thousand metric tons of CO2 equivalent) in 2005 in Australia to that in Canada?
Offer a terse response. 0.43. What is the ratio of the HFC emissions (in thousand metric tons of CO2 equivalent) in 2008 in Australia to that in Canada?
Provide a short and direct response. 0.44. What is the ratio of the HFC emissions (in thousand metric tons of CO2 equivalent) in 1990 in Australia to that in China?
Make the answer very short. 0.1. What is the ratio of the HFC emissions (in thousand metric tons of CO2 equivalent) of 2000 in Australia to that in China?
Your answer should be compact. 0.07. What is the ratio of the HFC emissions (in thousand metric tons of CO2 equivalent) in 2005 in Australia to that in China?
Give a very brief answer. 0.04. What is the ratio of the HFC emissions (in thousand metric tons of CO2 equivalent) in 2008 in Australia to that in China?
Offer a very short reply. 0.04. What is the ratio of the HFC emissions (in thousand metric tons of CO2 equivalent) in 1990 in Austria to that in Belgium?
Your answer should be compact. 61.8. What is the ratio of the HFC emissions (in thousand metric tons of CO2 equivalent) in 2000 in Austria to that in Belgium?
Keep it short and to the point. 1.02. What is the ratio of the HFC emissions (in thousand metric tons of CO2 equivalent) of 1990 in Austria to that in Brazil?
Your response must be concise. 0.02. What is the ratio of the HFC emissions (in thousand metric tons of CO2 equivalent) of 2000 in Austria to that in Brazil?
Make the answer very short. 6.91. What is the ratio of the HFC emissions (in thousand metric tons of CO2 equivalent) of 2005 in Austria to that in Brazil?
Your answer should be very brief. 1.05. What is the ratio of the HFC emissions (in thousand metric tons of CO2 equivalent) of 2008 in Austria to that in Brazil?
Make the answer very short. 0.91. What is the ratio of the HFC emissions (in thousand metric tons of CO2 equivalent) of 1990 in Austria to that in Canada?
Your answer should be very brief. 0.07. What is the ratio of the HFC emissions (in thousand metric tons of CO2 equivalent) of 2000 in Austria to that in Canada?
Offer a very short reply. 0.16. What is the ratio of the HFC emissions (in thousand metric tons of CO2 equivalent) of 2005 in Austria to that in Canada?
Give a very brief answer. 0.16. What is the ratio of the HFC emissions (in thousand metric tons of CO2 equivalent) of 2008 in Austria to that in Canada?
Ensure brevity in your answer.  0.16. What is the ratio of the HFC emissions (in thousand metric tons of CO2 equivalent) of 1990 in Austria to that in China?
Make the answer very short. 0.01. What is the ratio of the HFC emissions (in thousand metric tons of CO2 equivalent) in 2000 in Austria to that in China?
Your response must be concise. 0.03. What is the ratio of the HFC emissions (in thousand metric tons of CO2 equivalent) of 2005 in Austria to that in China?
Offer a terse response. 0.01. What is the ratio of the HFC emissions (in thousand metric tons of CO2 equivalent) in 2008 in Austria to that in China?
Offer a very short reply. 0.02. What is the ratio of the HFC emissions (in thousand metric tons of CO2 equivalent) in 2000 in Belgium to that in Brazil?
Keep it short and to the point. 6.77. What is the ratio of the HFC emissions (in thousand metric tons of CO2 equivalent) in 2005 in Belgium to that in Brazil?
Offer a terse response. 1.05. What is the ratio of the HFC emissions (in thousand metric tons of CO2 equivalent) of 2008 in Belgium to that in Brazil?
Ensure brevity in your answer.  0.91. What is the ratio of the HFC emissions (in thousand metric tons of CO2 equivalent) in 1990 in Belgium to that in Canada?
Ensure brevity in your answer.  0. What is the ratio of the HFC emissions (in thousand metric tons of CO2 equivalent) in 2000 in Belgium to that in Canada?
Your answer should be very brief. 0.16. What is the ratio of the HFC emissions (in thousand metric tons of CO2 equivalent) in 2005 in Belgium to that in Canada?
Your response must be concise. 0.16. What is the ratio of the HFC emissions (in thousand metric tons of CO2 equivalent) of 2008 in Belgium to that in Canada?
Make the answer very short. 0.16. What is the ratio of the HFC emissions (in thousand metric tons of CO2 equivalent) of 1990 in Belgium to that in China?
Offer a terse response. 0. What is the ratio of the HFC emissions (in thousand metric tons of CO2 equivalent) of 2000 in Belgium to that in China?
Your answer should be very brief. 0.03. What is the ratio of the HFC emissions (in thousand metric tons of CO2 equivalent) of 2005 in Belgium to that in China?
Offer a terse response. 0.01. What is the ratio of the HFC emissions (in thousand metric tons of CO2 equivalent) in 2008 in Belgium to that in China?
Offer a terse response. 0.02. What is the ratio of the HFC emissions (in thousand metric tons of CO2 equivalent) of 1990 in Brazil to that in Canada?
Give a very brief answer. 4.61. What is the ratio of the HFC emissions (in thousand metric tons of CO2 equivalent) in 2000 in Brazil to that in Canada?
Provide a succinct answer. 0.02. What is the ratio of the HFC emissions (in thousand metric tons of CO2 equivalent) of 2005 in Brazil to that in Canada?
Your answer should be very brief. 0.15. What is the ratio of the HFC emissions (in thousand metric tons of CO2 equivalent) of 2008 in Brazil to that in Canada?
Make the answer very short. 0.17. What is the ratio of the HFC emissions (in thousand metric tons of CO2 equivalent) in 1990 in Brazil to that in China?
Your response must be concise. 0.32. What is the ratio of the HFC emissions (in thousand metric tons of CO2 equivalent) in 2000 in Brazil to that in China?
Ensure brevity in your answer.  0. What is the ratio of the HFC emissions (in thousand metric tons of CO2 equivalent) in 2005 in Brazil to that in China?
Offer a very short reply. 0.01. What is the ratio of the HFC emissions (in thousand metric tons of CO2 equivalent) of 2008 in Brazil to that in China?
Offer a terse response. 0.02. What is the ratio of the HFC emissions (in thousand metric tons of CO2 equivalent) of 1990 in Canada to that in China?
Keep it short and to the point. 0.07. What is the ratio of the HFC emissions (in thousand metric tons of CO2 equivalent) of 2000 in Canada to that in China?
Ensure brevity in your answer.  0.16. What is the ratio of the HFC emissions (in thousand metric tons of CO2 equivalent) in 2005 in Canada to that in China?
Provide a short and direct response. 0.08. What is the ratio of the HFC emissions (in thousand metric tons of CO2 equivalent) of 2008 in Canada to that in China?
Your response must be concise. 0.1. What is the difference between the highest and the second highest HFC emissions (in thousand metric tons of CO2 equivalent) of 1990?
Provide a succinct answer. 4039.4. What is the difference between the highest and the second highest HFC emissions (in thousand metric tons of CO2 equivalent) of 2000?
Offer a very short reply. 3.19e+04. What is the difference between the highest and the second highest HFC emissions (in thousand metric tons of CO2 equivalent) in 2005?
Offer a terse response. 1.35e+05. What is the difference between the highest and the second highest HFC emissions (in thousand metric tons of CO2 equivalent) in 2008?
Your response must be concise. 1.38e+05. What is the difference between the highest and the lowest HFC emissions (in thousand metric tons of CO2 equivalent) in 1990?
Your response must be concise. 5969.6. What is the difference between the highest and the lowest HFC emissions (in thousand metric tons of CO2 equivalent) in 2000?
Your response must be concise. 3.79e+04. What is the difference between the highest and the lowest HFC emissions (in thousand metric tons of CO2 equivalent) in 2005?
Provide a short and direct response. 1.45e+05. What is the difference between the highest and the lowest HFC emissions (in thousand metric tons of CO2 equivalent) in 2008?
Your answer should be compact. 1.51e+05. 